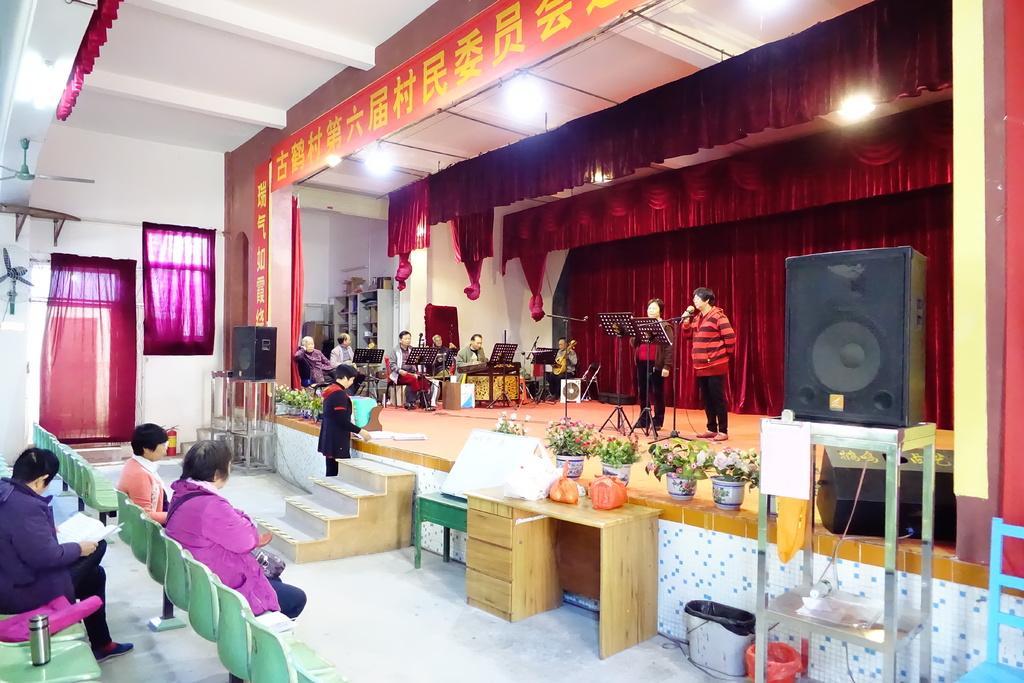Please provide a concise description of this image. This picture contains an auditorium in which many people are sitting on chair and playing musical instruments. In the middle of an Auditorium, we see two women singing on a microphone. Beside them, we see speaker. Behind them, we see a cloth which is red in color. In the middle of the picture, we see staircase. On stage, we see money flower pots. On the left bottom of the picture, there are many green chairs and three people sat on three chairs. 